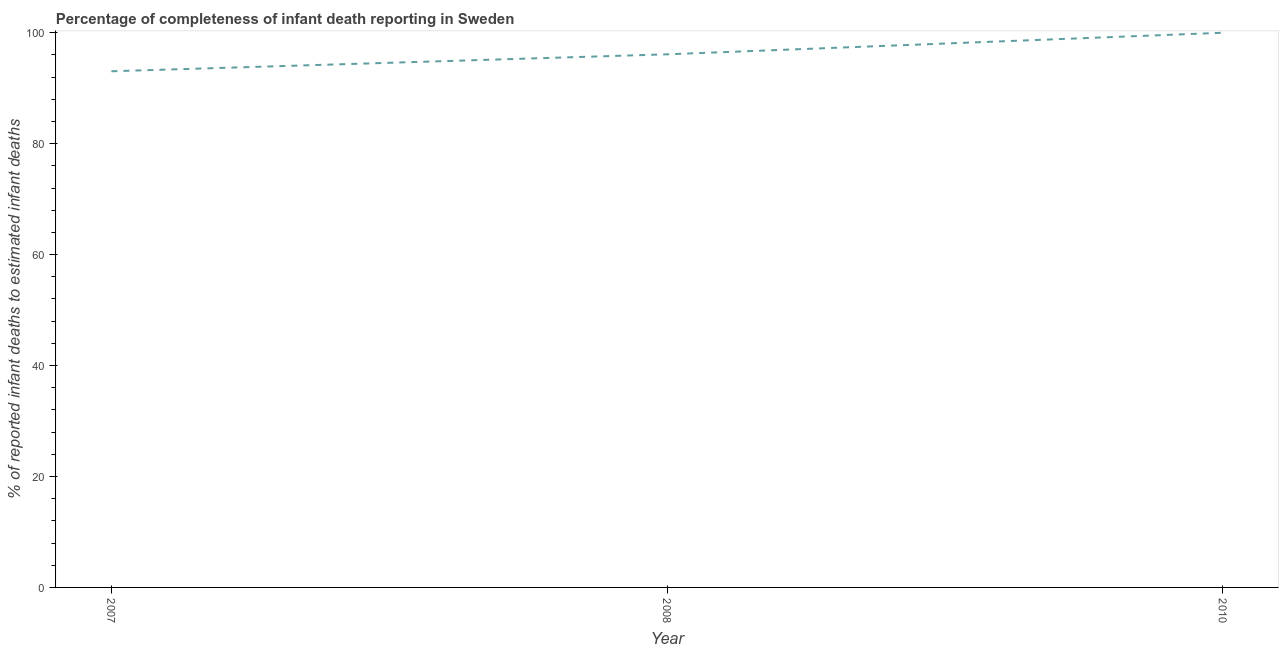What is the completeness of infant death reporting in 2008?
Provide a succinct answer. 96.11. Across all years, what is the maximum completeness of infant death reporting?
Give a very brief answer. 100. Across all years, what is the minimum completeness of infant death reporting?
Keep it short and to the point. 93.06. In which year was the completeness of infant death reporting maximum?
Make the answer very short. 2010. In which year was the completeness of infant death reporting minimum?
Ensure brevity in your answer.  2007. What is the sum of the completeness of infant death reporting?
Your answer should be very brief. 289.17. What is the difference between the completeness of infant death reporting in 2008 and 2010?
Offer a very short reply. -3.89. What is the average completeness of infant death reporting per year?
Provide a short and direct response. 96.39. What is the median completeness of infant death reporting?
Give a very brief answer. 96.11. Do a majority of the years between 2010 and 2007 (inclusive) have completeness of infant death reporting greater than 72 %?
Provide a succinct answer. No. What is the ratio of the completeness of infant death reporting in 2007 to that in 2010?
Offer a very short reply. 0.93. Is the difference between the completeness of infant death reporting in 2007 and 2010 greater than the difference between any two years?
Provide a succinct answer. Yes. What is the difference between the highest and the second highest completeness of infant death reporting?
Provide a succinct answer. 3.89. Is the sum of the completeness of infant death reporting in 2007 and 2010 greater than the maximum completeness of infant death reporting across all years?
Provide a succinct answer. Yes. What is the difference between the highest and the lowest completeness of infant death reporting?
Provide a succinct answer. 6.94. Does the completeness of infant death reporting monotonically increase over the years?
Offer a very short reply. Yes. How many years are there in the graph?
Offer a terse response. 3. What is the difference between two consecutive major ticks on the Y-axis?
Give a very brief answer. 20. Are the values on the major ticks of Y-axis written in scientific E-notation?
Provide a short and direct response. No. Does the graph contain grids?
Your answer should be compact. No. What is the title of the graph?
Your answer should be compact. Percentage of completeness of infant death reporting in Sweden. What is the label or title of the X-axis?
Your response must be concise. Year. What is the label or title of the Y-axis?
Your response must be concise. % of reported infant deaths to estimated infant deaths. What is the % of reported infant deaths to estimated infant deaths in 2007?
Offer a very short reply. 93.06. What is the % of reported infant deaths to estimated infant deaths of 2008?
Ensure brevity in your answer.  96.11. What is the % of reported infant deaths to estimated infant deaths in 2010?
Keep it short and to the point. 100. What is the difference between the % of reported infant deaths to estimated infant deaths in 2007 and 2008?
Offer a very short reply. -3.06. What is the difference between the % of reported infant deaths to estimated infant deaths in 2007 and 2010?
Ensure brevity in your answer.  -6.94. What is the difference between the % of reported infant deaths to estimated infant deaths in 2008 and 2010?
Provide a succinct answer. -3.89. What is the ratio of the % of reported infant deaths to estimated infant deaths in 2007 to that in 2010?
Provide a short and direct response. 0.93. What is the ratio of the % of reported infant deaths to estimated infant deaths in 2008 to that in 2010?
Keep it short and to the point. 0.96. 